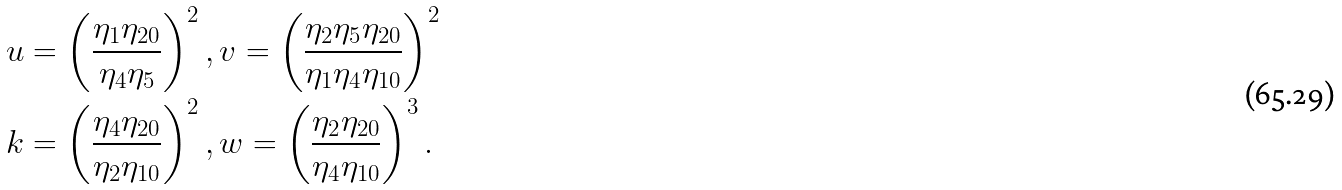Convert formula to latex. <formula><loc_0><loc_0><loc_500><loc_500>u & = \left ( \frac { \eta _ { 1 } \eta _ { 2 0 } } { \eta _ { 4 } \eta _ { 5 } } \right ) ^ { 2 } , v = \left ( \frac { \eta _ { 2 } \eta _ { 5 } \eta _ { 2 0 } } { \eta _ { 1 } \eta _ { 4 } \eta _ { 1 0 } } \right ) ^ { 2 } \\ k & = \left ( \frac { \eta _ { 4 } \eta _ { 2 0 } } { \eta _ { 2 } \eta _ { 1 0 } } \right ) ^ { 2 } , w = \left ( \frac { \eta _ { 2 } \eta _ { 2 0 } } { \eta _ { 4 } \eta _ { 1 0 } } \right ) ^ { 3 } .</formula> 